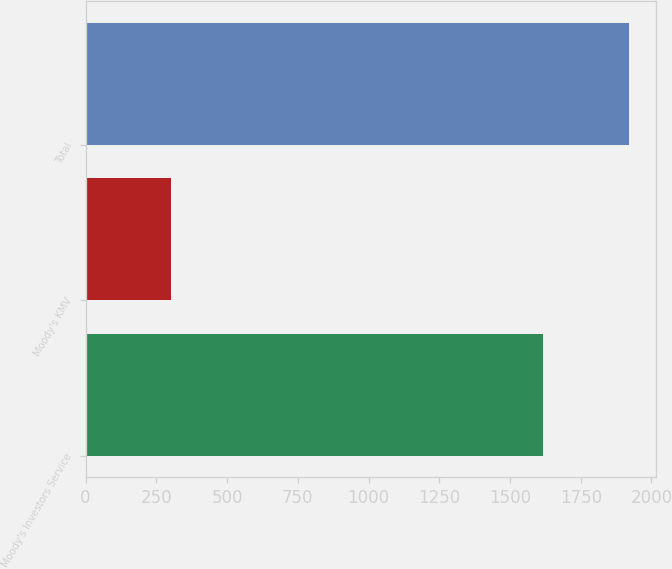Convert chart to OTSL. <chart><loc_0><loc_0><loc_500><loc_500><bar_chart><fcel>Moody's Investors Service<fcel>Moody's KMV<fcel>Total<nl><fcel>1617<fcel>303<fcel>1920<nl></chart> 